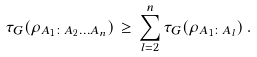Convert formula to latex. <formula><loc_0><loc_0><loc_500><loc_500>\tau _ { G } ( \rho _ { A _ { 1 } \colon A _ { 2 } \dots A _ { n } } ) \, \geq \, \sum _ { l = 2 } ^ { n } \tau _ { G } ( \rho _ { A _ { 1 } \colon A _ { l } } ) \, .</formula> 